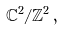Convert formula to latex. <formula><loc_0><loc_0><loc_500><loc_500>\mathbb { C } ^ { 2 } / \mathbb { Z } ^ { 2 } \, ,</formula> 